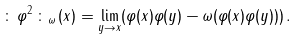Convert formula to latex. <formula><loc_0><loc_0><loc_500><loc_500>\colon \, \varphi ^ { 2 } \, \colon _ { \omega } \, ( x ) = \lim _ { y \to x } ( \varphi ( x ) \varphi ( y ) - \omega ( \varphi ( x ) \varphi ( y ) ) ) \, .</formula> 